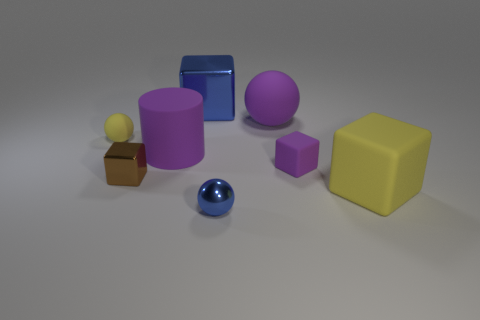Subtract 1 blocks. How many blocks are left? 3 Add 1 yellow rubber cubes. How many objects exist? 9 Subtract all spheres. How many objects are left? 5 Add 5 purple things. How many purple things are left? 8 Add 7 purple matte cylinders. How many purple matte cylinders exist? 8 Subtract 0 green spheres. How many objects are left? 8 Subtract all blue matte cylinders. Subtract all tiny brown metal things. How many objects are left? 7 